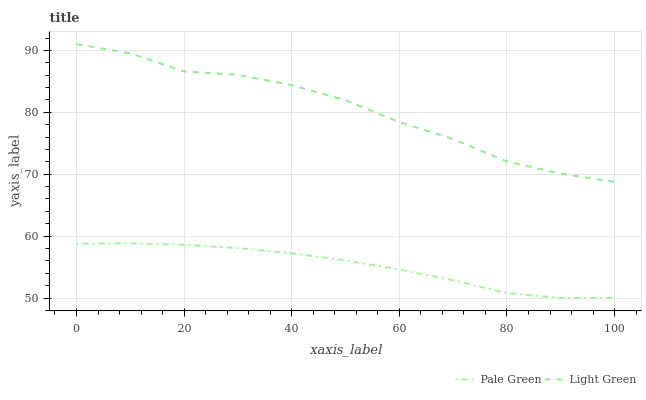Does Light Green have the minimum area under the curve?
Answer yes or no. No. Is Light Green the smoothest?
Answer yes or no. No. Does Light Green have the lowest value?
Answer yes or no. No. Is Pale Green less than Light Green?
Answer yes or no. Yes. Is Light Green greater than Pale Green?
Answer yes or no. Yes. Does Pale Green intersect Light Green?
Answer yes or no. No. 